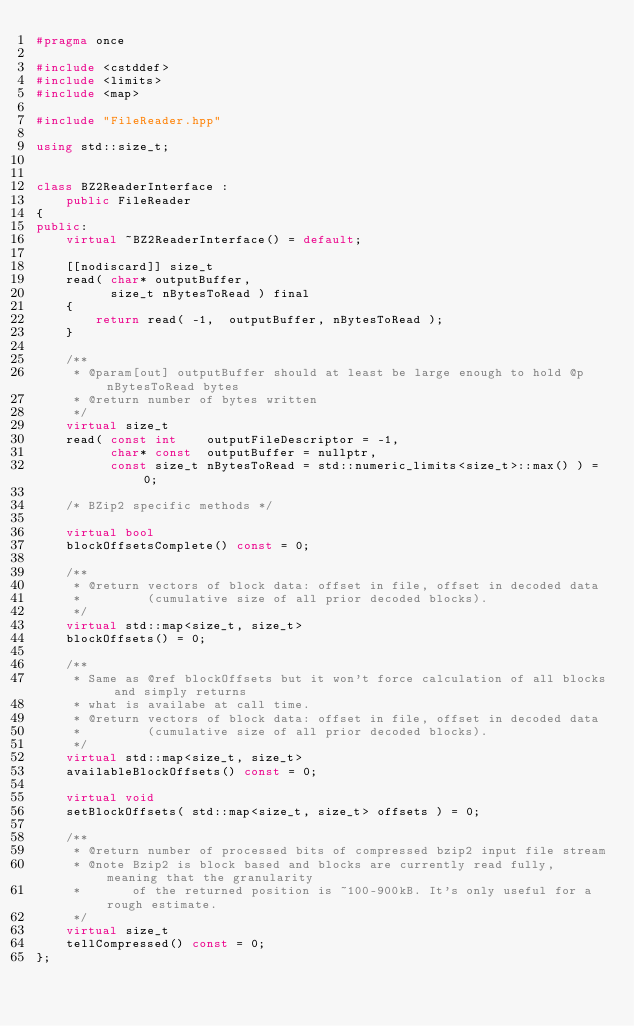<code> <loc_0><loc_0><loc_500><loc_500><_C++_>#pragma once

#include <cstddef>
#include <limits>
#include <map>

#include "FileReader.hpp"

using std::size_t;


class BZ2ReaderInterface :
    public FileReader
{
public:
    virtual ~BZ2ReaderInterface() = default;

    [[nodiscard]] size_t
    read( char* outputBuffer,
          size_t nBytesToRead ) final
    {
        return read( -1,  outputBuffer, nBytesToRead );
    }

    /**
     * @param[out] outputBuffer should at least be large enough to hold @p nBytesToRead bytes
     * @return number of bytes written
     */
    virtual size_t
    read( const int    outputFileDescriptor = -1,
          char* const  outputBuffer = nullptr,
          const size_t nBytesToRead = std::numeric_limits<size_t>::max() ) = 0;

    /* BZip2 specific methods */

    virtual bool
    blockOffsetsComplete() const = 0;

    /**
     * @return vectors of block data: offset in file, offset in decoded data
     *         (cumulative size of all prior decoded blocks).
     */
    virtual std::map<size_t, size_t>
    blockOffsets() = 0;

    /**
     * Same as @ref blockOffsets but it won't force calculation of all blocks and simply returns
     * what is availabe at call time.
     * @return vectors of block data: offset in file, offset in decoded data
     *         (cumulative size of all prior decoded blocks).
     */
    virtual std::map<size_t, size_t>
    availableBlockOffsets() const = 0;

    virtual void
    setBlockOffsets( std::map<size_t, size_t> offsets ) = 0;

    /**
     * @return number of processed bits of compressed bzip2 input file stream
     * @note Bzip2 is block based and blocks are currently read fully, meaning that the granularity
     *       of the returned position is ~100-900kB. It's only useful for a rough estimate.
     */
    virtual size_t
    tellCompressed() const = 0;
};
</code> 